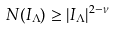<formula> <loc_0><loc_0><loc_500><loc_500>N ( I _ { \Lambda } ) \geq | I _ { \Lambda } | ^ { 2 - \nu }</formula> 